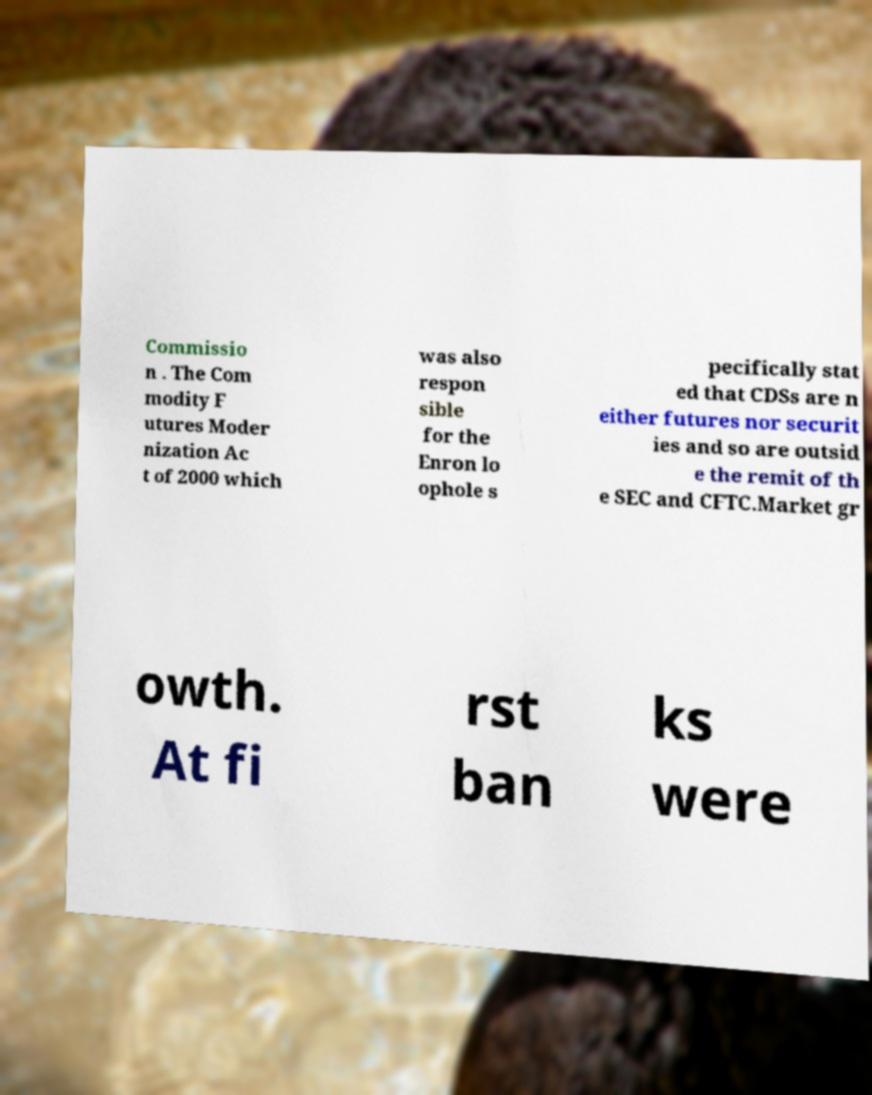What messages or text are displayed in this image? I need them in a readable, typed format. Commissio n . The Com modity F utures Moder nization Ac t of 2000 which was also respon sible for the Enron lo ophole s pecifically stat ed that CDSs are n either futures nor securit ies and so are outsid e the remit of th e SEC and CFTC.Market gr owth. At fi rst ban ks were 